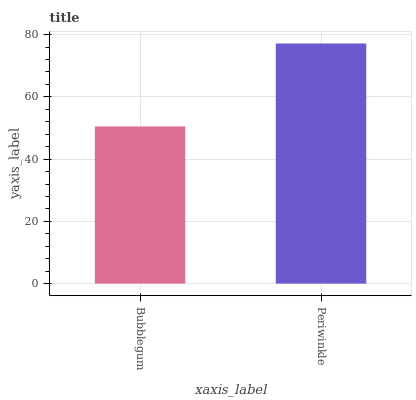Is Bubblegum the minimum?
Answer yes or no. Yes. Is Periwinkle the maximum?
Answer yes or no. Yes. Is Periwinkle the minimum?
Answer yes or no. No. Is Periwinkle greater than Bubblegum?
Answer yes or no. Yes. Is Bubblegum less than Periwinkle?
Answer yes or no. Yes. Is Bubblegum greater than Periwinkle?
Answer yes or no. No. Is Periwinkle less than Bubblegum?
Answer yes or no. No. Is Periwinkle the high median?
Answer yes or no. Yes. Is Bubblegum the low median?
Answer yes or no. Yes. Is Bubblegum the high median?
Answer yes or no. No. Is Periwinkle the low median?
Answer yes or no. No. 